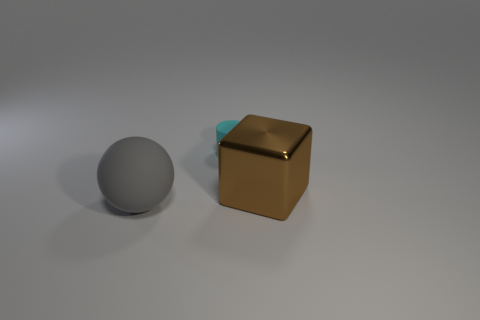Is there anything else that is the same material as the brown block?
Your response must be concise. No. How many objects are either cyan rubber cylinders or matte things that are behind the large brown cube?
Keep it short and to the point. 1. Do the gray ball and the large brown block have the same material?
Provide a succinct answer. No. Are there an equal number of objects to the right of the gray ball and gray things behind the metallic thing?
Provide a short and direct response. No. There is a big gray thing; how many big brown shiny things are left of it?
Ensure brevity in your answer.  0. How many things are either yellow balls or matte objects?
Give a very brief answer. 2. How many other brown metal blocks have the same size as the brown cube?
Offer a terse response. 0. The matte thing in front of the large thing that is on the right side of the gray ball is what shape?
Offer a very short reply. Sphere. Are there fewer brown metal things than small blue metallic spheres?
Provide a succinct answer. No. What is the color of the matte object that is to the right of the big gray rubber sphere?
Provide a succinct answer. Cyan. 